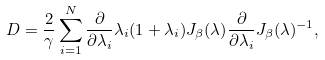Convert formula to latex. <formula><loc_0><loc_0><loc_500><loc_500>D = \frac { 2 } { \gamma } \sum _ { i = 1 } ^ { N } \frac { \partial } { \partial \lambda _ { i } } \lambda _ { i } ( 1 + \lambda _ { i } ) J _ { \beta } ( \lambda ) \frac { \partial } { \partial \lambda _ { i } } J _ { \beta } ( \lambda ) ^ { - 1 } ,</formula> 